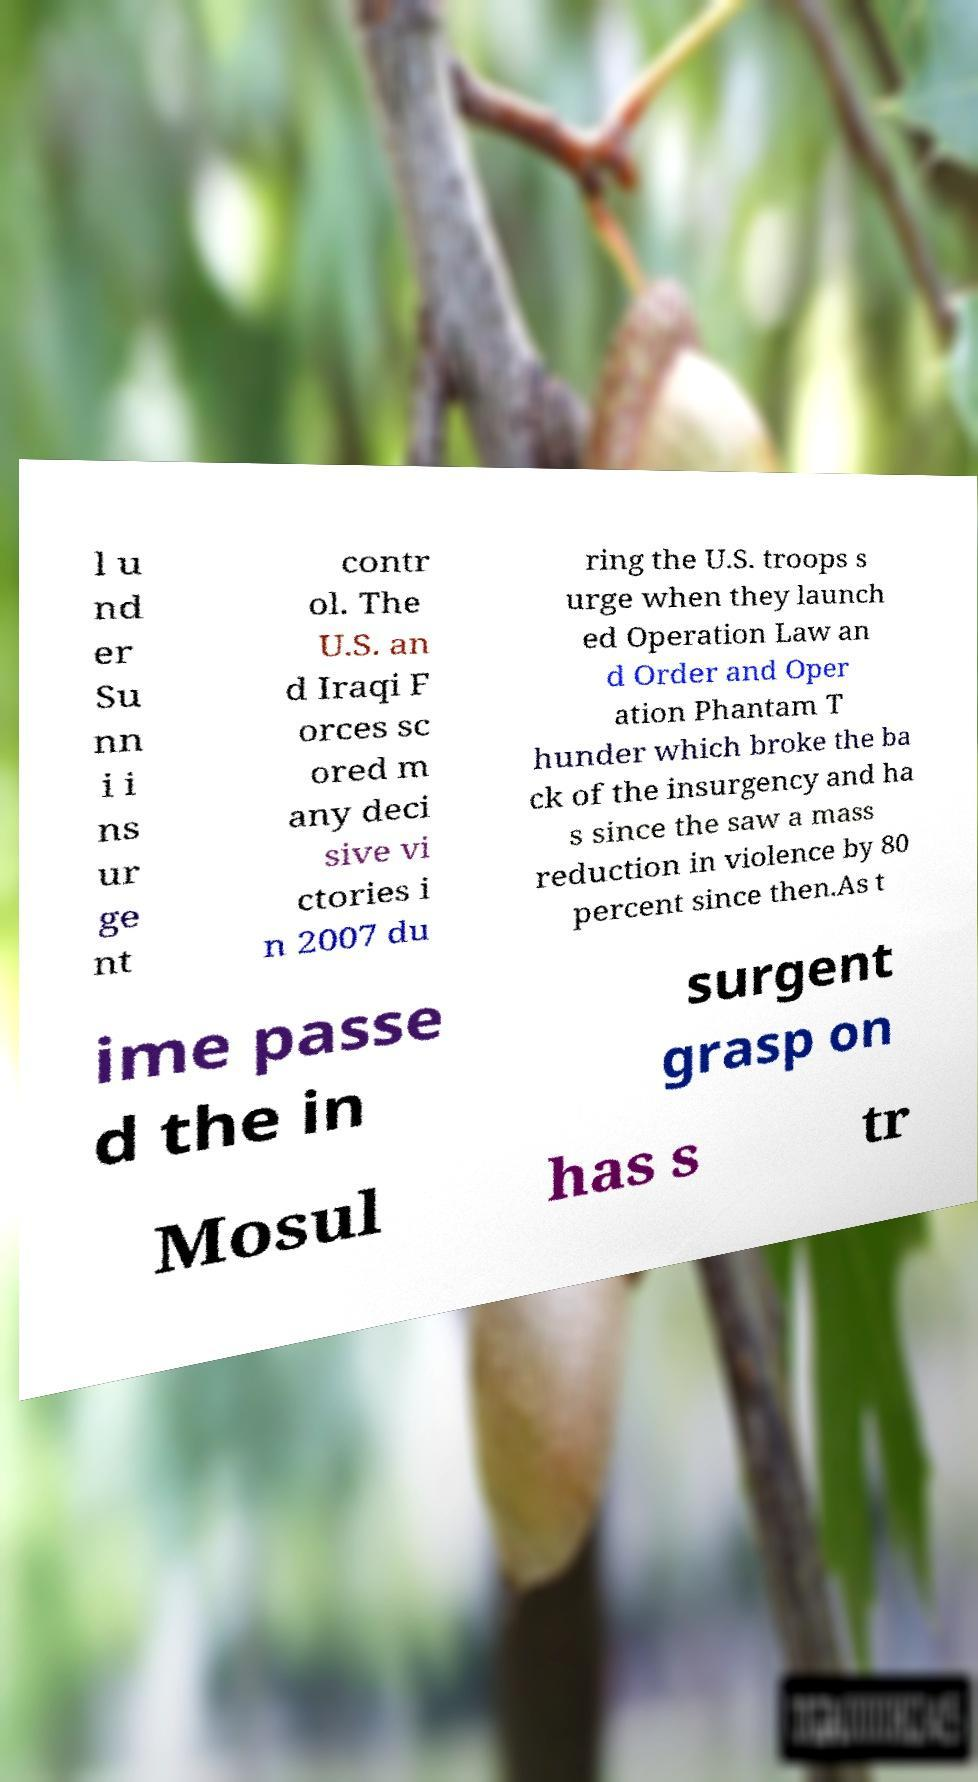There's text embedded in this image that I need extracted. Can you transcribe it verbatim? l u nd er Su nn i i ns ur ge nt contr ol. The U.S. an d Iraqi F orces sc ored m any deci sive vi ctories i n 2007 du ring the U.S. troops s urge when they launch ed Operation Law an d Order and Oper ation Phantam T hunder which broke the ba ck of the insurgency and ha s since the saw a mass reduction in violence by 80 percent since then.As t ime passe d the in surgent grasp on Mosul has s tr 